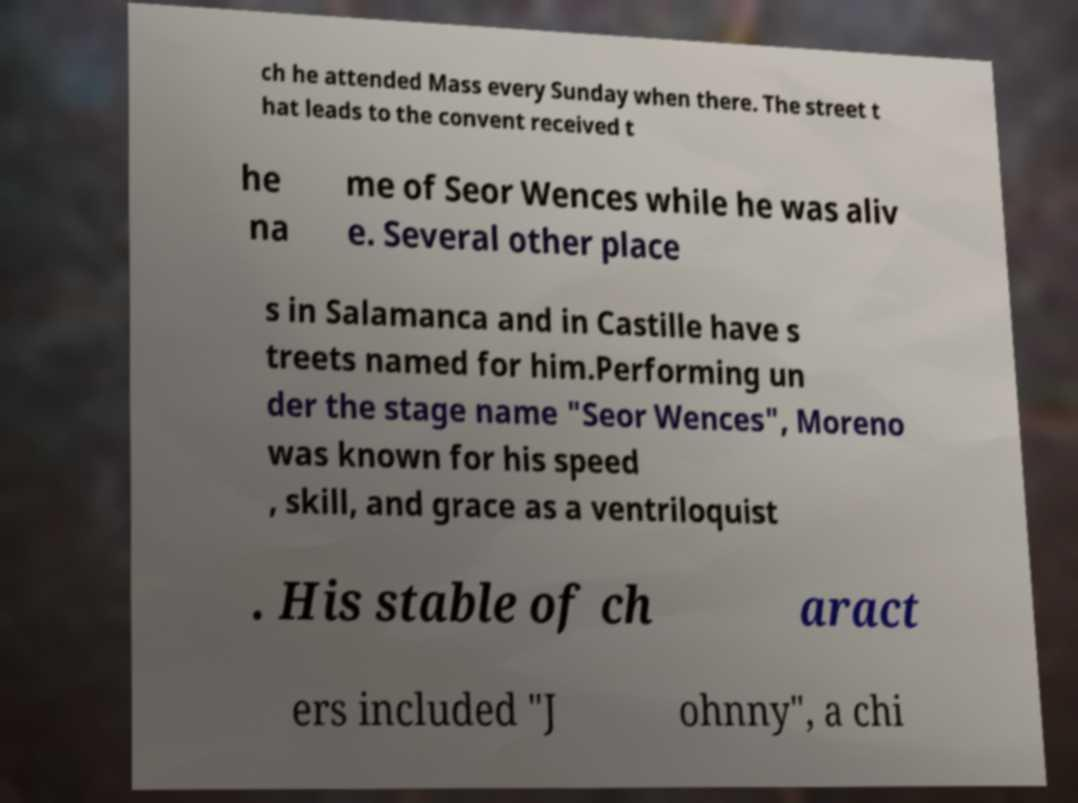There's text embedded in this image that I need extracted. Can you transcribe it verbatim? ch he attended Mass every Sunday when there. The street t hat leads to the convent received t he na me of Seor Wences while he was aliv e. Several other place s in Salamanca and in Castille have s treets named for him.Performing un der the stage name "Seor Wences", Moreno was known for his speed , skill, and grace as a ventriloquist . His stable of ch aract ers included "J ohnny", a chi 